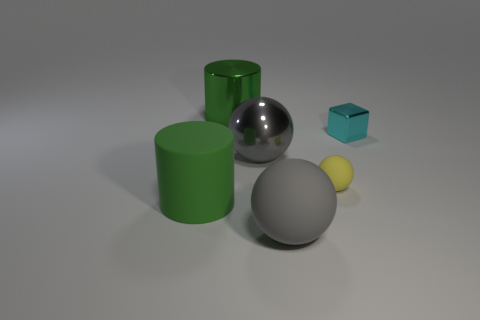Subtract all big gray matte spheres. How many spheres are left? 2 Subtract all red blocks. How many gray balls are left? 2 Add 3 big shiny objects. How many objects exist? 9 Subtract 1 green cylinders. How many objects are left? 5 Subtract all blocks. How many objects are left? 5 Subtract all large green metallic things. Subtract all matte cylinders. How many objects are left? 4 Add 3 big cylinders. How many big cylinders are left? 5 Add 1 tiny brown spheres. How many tiny brown spheres exist? 1 